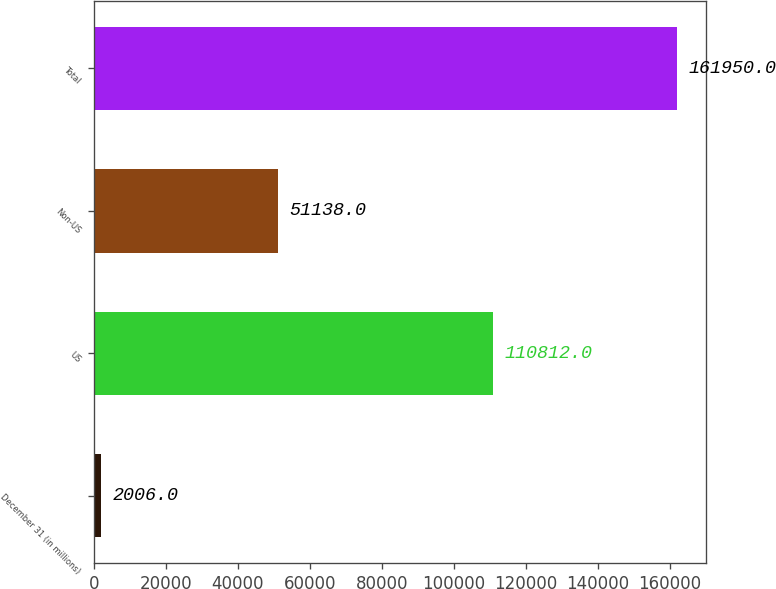<chart> <loc_0><loc_0><loc_500><loc_500><bar_chart><fcel>December 31 (in millions)<fcel>US<fcel>Non-US<fcel>Total<nl><fcel>2006<fcel>110812<fcel>51138<fcel>161950<nl></chart> 